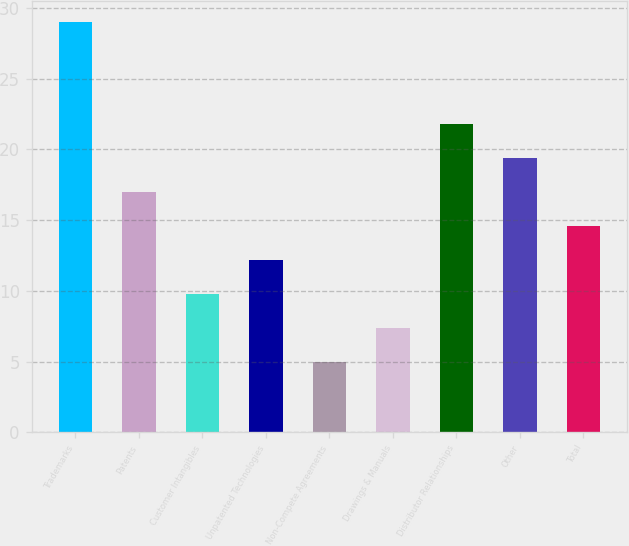Convert chart. <chart><loc_0><loc_0><loc_500><loc_500><bar_chart><fcel>Trademarks<fcel>Patents<fcel>Customer Intangibles<fcel>Unpatented Technologies<fcel>Non-Compete Agreements<fcel>Drawings & Manuals<fcel>Distributor Relationships<fcel>Other<fcel>Total<nl><fcel>29<fcel>17<fcel>9.8<fcel>12.2<fcel>5<fcel>7.4<fcel>21.8<fcel>19.4<fcel>14.6<nl></chart> 